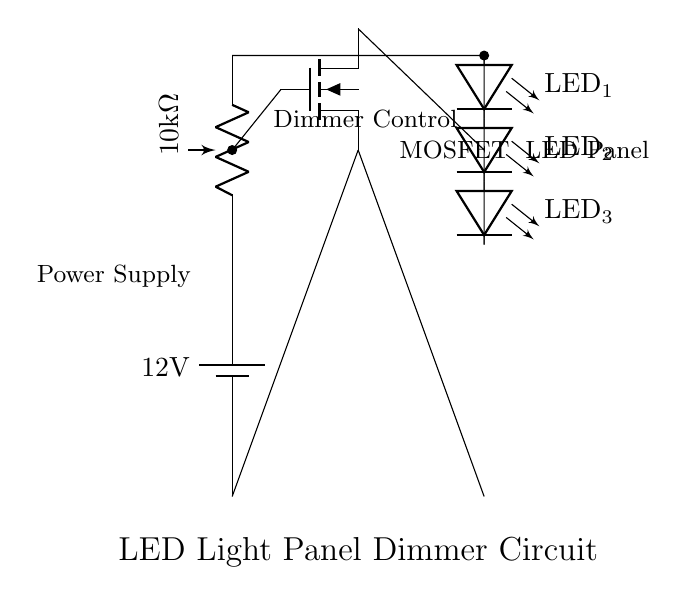What is the power supply voltage? The circuit diagram shows a battery with a label indicating 12V, which is the voltage supplied to the circuit.
Answer: 12V What type of control component is used in this circuit? The circuit includes a potentiometer which is typically used for adjusting resistance, indicating that it is used for dimmer control.
Answer: Potentiometer What is the resistance value of the potentiometer? The potentiometer is labeled as 10 k ohm, which specifies its resistance value in the circuit.
Answer: 10 k ohm How many LEDs are in the LED panel? The diagram shows three distinct LED components labeled LED 1, LED 2, and LED 3, totaling three in the array.
Answer: 3 Why is a MOSFET used in this circuit? The MOSFET acts as a switch that is controlled by the gate, allowing for adjustment of the brightness of the LEDs based on the potentiometer setting, thus controlling the current flow.
Answer: To control brightness Where is the source terminal of the MOSFET connected? The source terminal of the MOSFET connects directly to the ground, as represented in the lower section of the circuit.
Answer: Ground What do the labels on the LEDs signify? The labels on the LEDs indicate that they are individual light-emitting diodes that make up the LED panel, showing their identifiable positions.
Answer: LED identifiers 